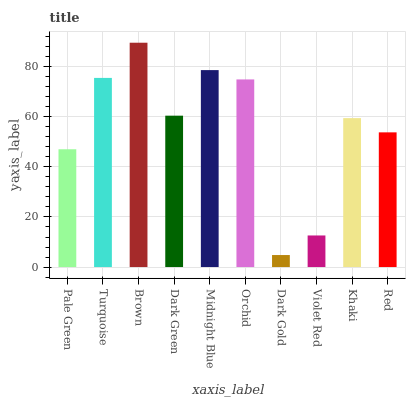Is Dark Gold the minimum?
Answer yes or no. Yes. Is Brown the maximum?
Answer yes or no. Yes. Is Turquoise the minimum?
Answer yes or no. No. Is Turquoise the maximum?
Answer yes or no. No. Is Turquoise greater than Pale Green?
Answer yes or no. Yes. Is Pale Green less than Turquoise?
Answer yes or no. Yes. Is Pale Green greater than Turquoise?
Answer yes or no. No. Is Turquoise less than Pale Green?
Answer yes or no. No. Is Dark Green the high median?
Answer yes or no. Yes. Is Khaki the low median?
Answer yes or no. Yes. Is Violet Red the high median?
Answer yes or no. No. Is Pale Green the low median?
Answer yes or no. No. 